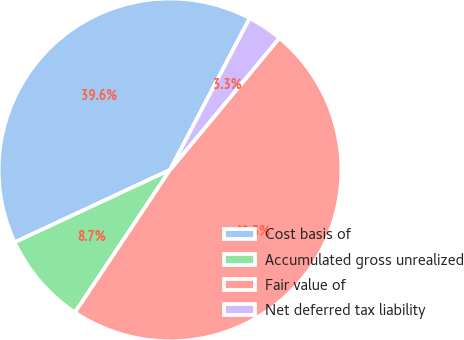<chart> <loc_0><loc_0><loc_500><loc_500><pie_chart><fcel>Cost basis of<fcel>Accumulated gross unrealized<fcel>Fair value of<fcel>Net deferred tax liability<nl><fcel>39.64%<fcel>8.7%<fcel>48.34%<fcel>3.32%<nl></chart> 